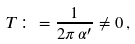<formula> <loc_0><loc_0><loc_500><loc_500>T \colon = \frac { 1 } { 2 \pi \, \alpha ^ { \prime } } \ne 0 \, ,</formula> 